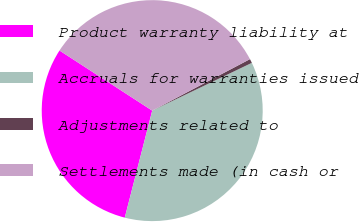Convert chart to OTSL. <chart><loc_0><loc_0><loc_500><loc_500><pie_chart><fcel>Product warranty liability at<fcel>Accruals for warranties issued<fcel>Adjustments related to<fcel>Settlements made (in cash or<nl><fcel>30.16%<fcel>36.11%<fcel>0.6%<fcel>33.13%<nl></chart> 